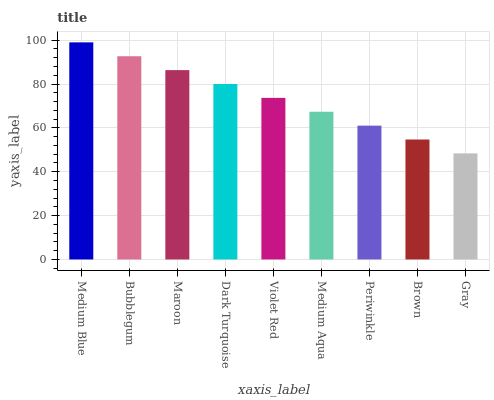Is Gray the minimum?
Answer yes or no. Yes. Is Medium Blue the maximum?
Answer yes or no. Yes. Is Bubblegum the minimum?
Answer yes or no. No. Is Bubblegum the maximum?
Answer yes or no. No. Is Medium Blue greater than Bubblegum?
Answer yes or no. Yes. Is Bubblegum less than Medium Blue?
Answer yes or no. Yes. Is Bubblegum greater than Medium Blue?
Answer yes or no. No. Is Medium Blue less than Bubblegum?
Answer yes or no. No. Is Violet Red the high median?
Answer yes or no. Yes. Is Violet Red the low median?
Answer yes or no. Yes. Is Periwinkle the high median?
Answer yes or no. No. Is Dark Turquoise the low median?
Answer yes or no. No. 